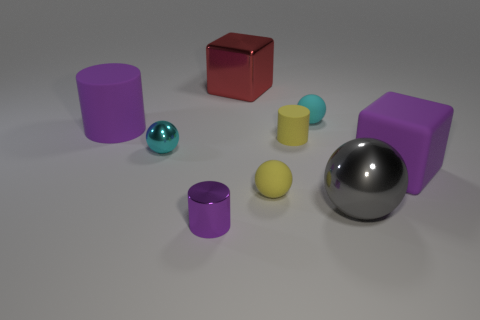Is the big purple thing that is behind the large purple matte block made of the same material as the cylinder in front of the purple rubber cube?
Your answer should be very brief. No. The big thing that is on the right side of the gray metallic thing that is on the right side of the tiny yellow object that is in front of the tiny yellow cylinder is what shape?
Make the answer very short. Cube. Is the number of big purple matte blocks greater than the number of brown objects?
Your answer should be very brief. Yes. Is there a yellow matte cylinder?
Your answer should be compact. Yes. What number of things are spheres that are to the left of the big red metallic cube or small balls that are left of the yellow sphere?
Ensure brevity in your answer.  1. Is the color of the metal cylinder the same as the large rubber cylinder?
Offer a very short reply. Yes. Are there fewer red metal things than green metal objects?
Provide a short and direct response. No. There is a red shiny object; are there any cylinders on the right side of it?
Make the answer very short. Yes. Is the red cube made of the same material as the big purple cube?
Give a very brief answer. No. There is a small metallic thing that is the same shape as the big gray thing; what is its color?
Offer a very short reply. Cyan. 